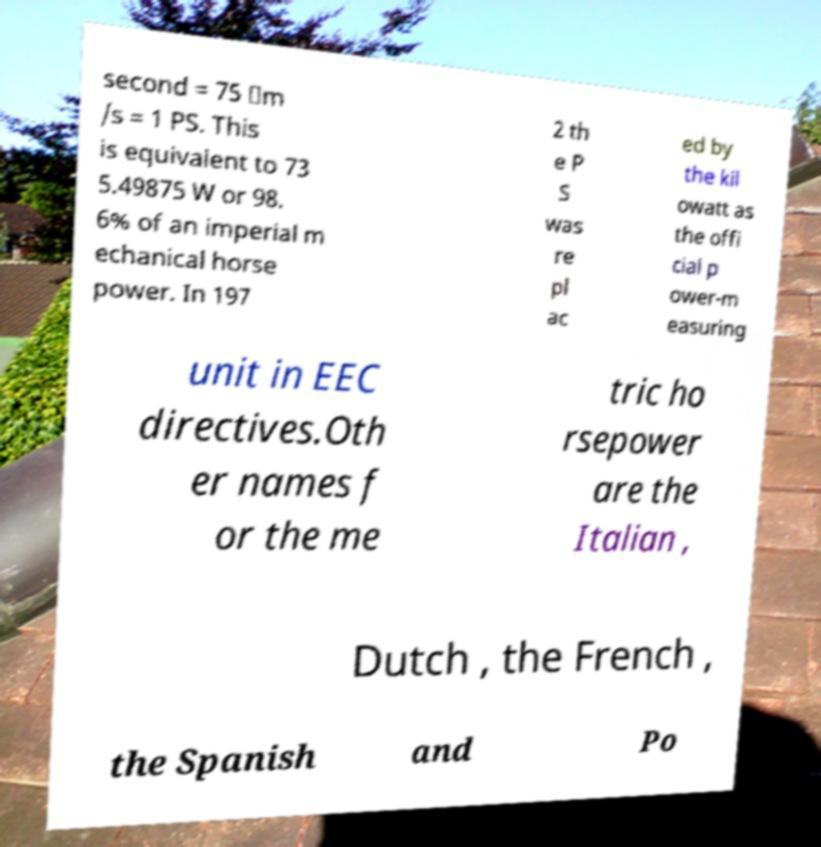There's text embedded in this image that I need extracted. Can you transcribe it verbatim? second = 75 ⋅m /s = 1 PS. This is equivalent to 73 5.49875 W or 98. 6% of an imperial m echanical horse power. In 197 2 th e P S was re pl ac ed by the kil owatt as the offi cial p ower-m easuring unit in EEC directives.Oth er names f or the me tric ho rsepower are the Italian , Dutch , the French , the Spanish and Po 